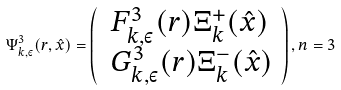Convert formula to latex. <formula><loc_0><loc_0><loc_500><loc_500>\Psi _ { k , \varepsilon } ^ { 3 } ( r , \hat { x } ) = \left ( \begin{array} { c c } F ^ { 3 } _ { k , \varepsilon } ( r ) \Xi ^ { + } _ { k } ( \hat { x } ) \\ \, G ^ { 3 } _ { k , \varepsilon } ( r ) \Xi ^ { - } _ { k } ( \hat { x } ) \end{array} \right ) , n = 3</formula> 